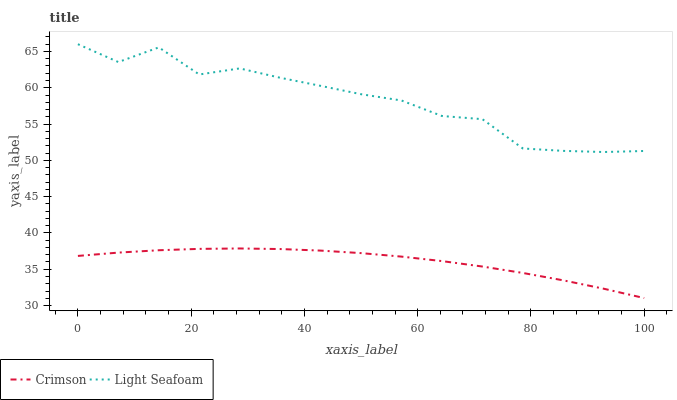Does Crimson have the minimum area under the curve?
Answer yes or no. Yes. Does Light Seafoam have the maximum area under the curve?
Answer yes or no. Yes. Does Light Seafoam have the minimum area under the curve?
Answer yes or no. No. Is Crimson the smoothest?
Answer yes or no. Yes. Is Light Seafoam the roughest?
Answer yes or no. Yes. Is Light Seafoam the smoothest?
Answer yes or no. No. Does Crimson have the lowest value?
Answer yes or no. Yes. Does Light Seafoam have the lowest value?
Answer yes or no. No. Does Light Seafoam have the highest value?
Answer yes or no. Yes. Is Crimson less than Light Seafoam?
Answer yes or no. Yes. Is Light Seafoam greater than Crimson?
Answer yes or no. Yes. Does Crimson intersect Light Seafoam?
Answer yes or no. No. 